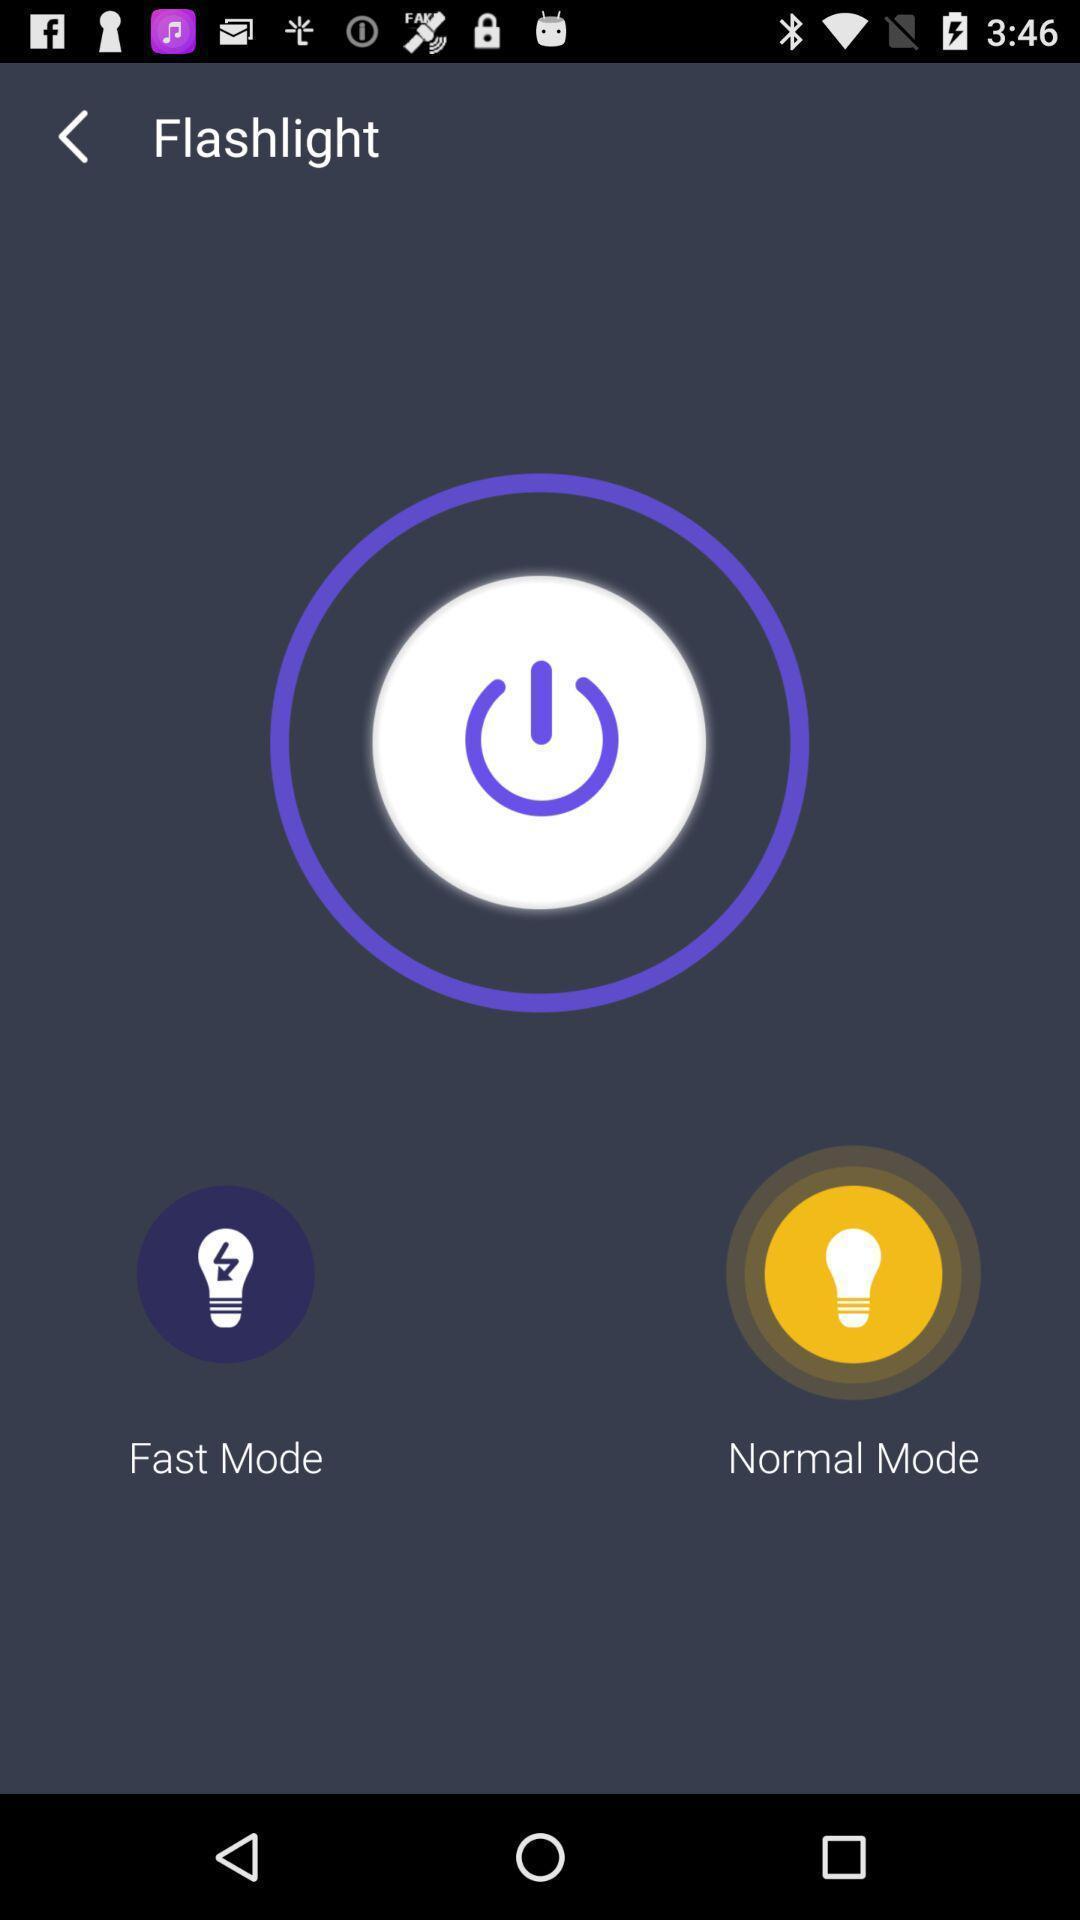Describe this image in words. Screen shows two flashlight modes. 